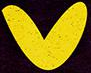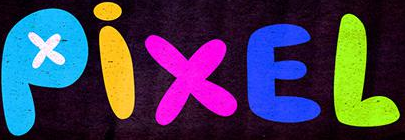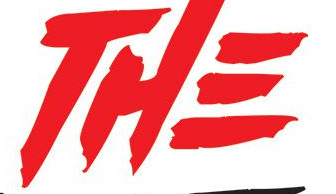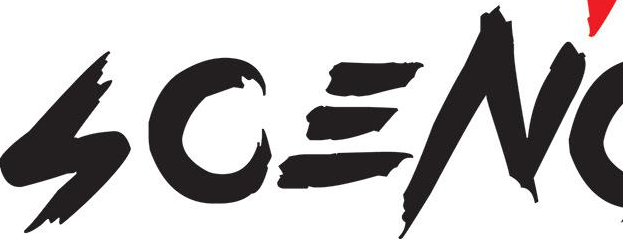What text is displayed in these images sequentially, separated by a semicolon? v; PixEL; THE; SCEN 